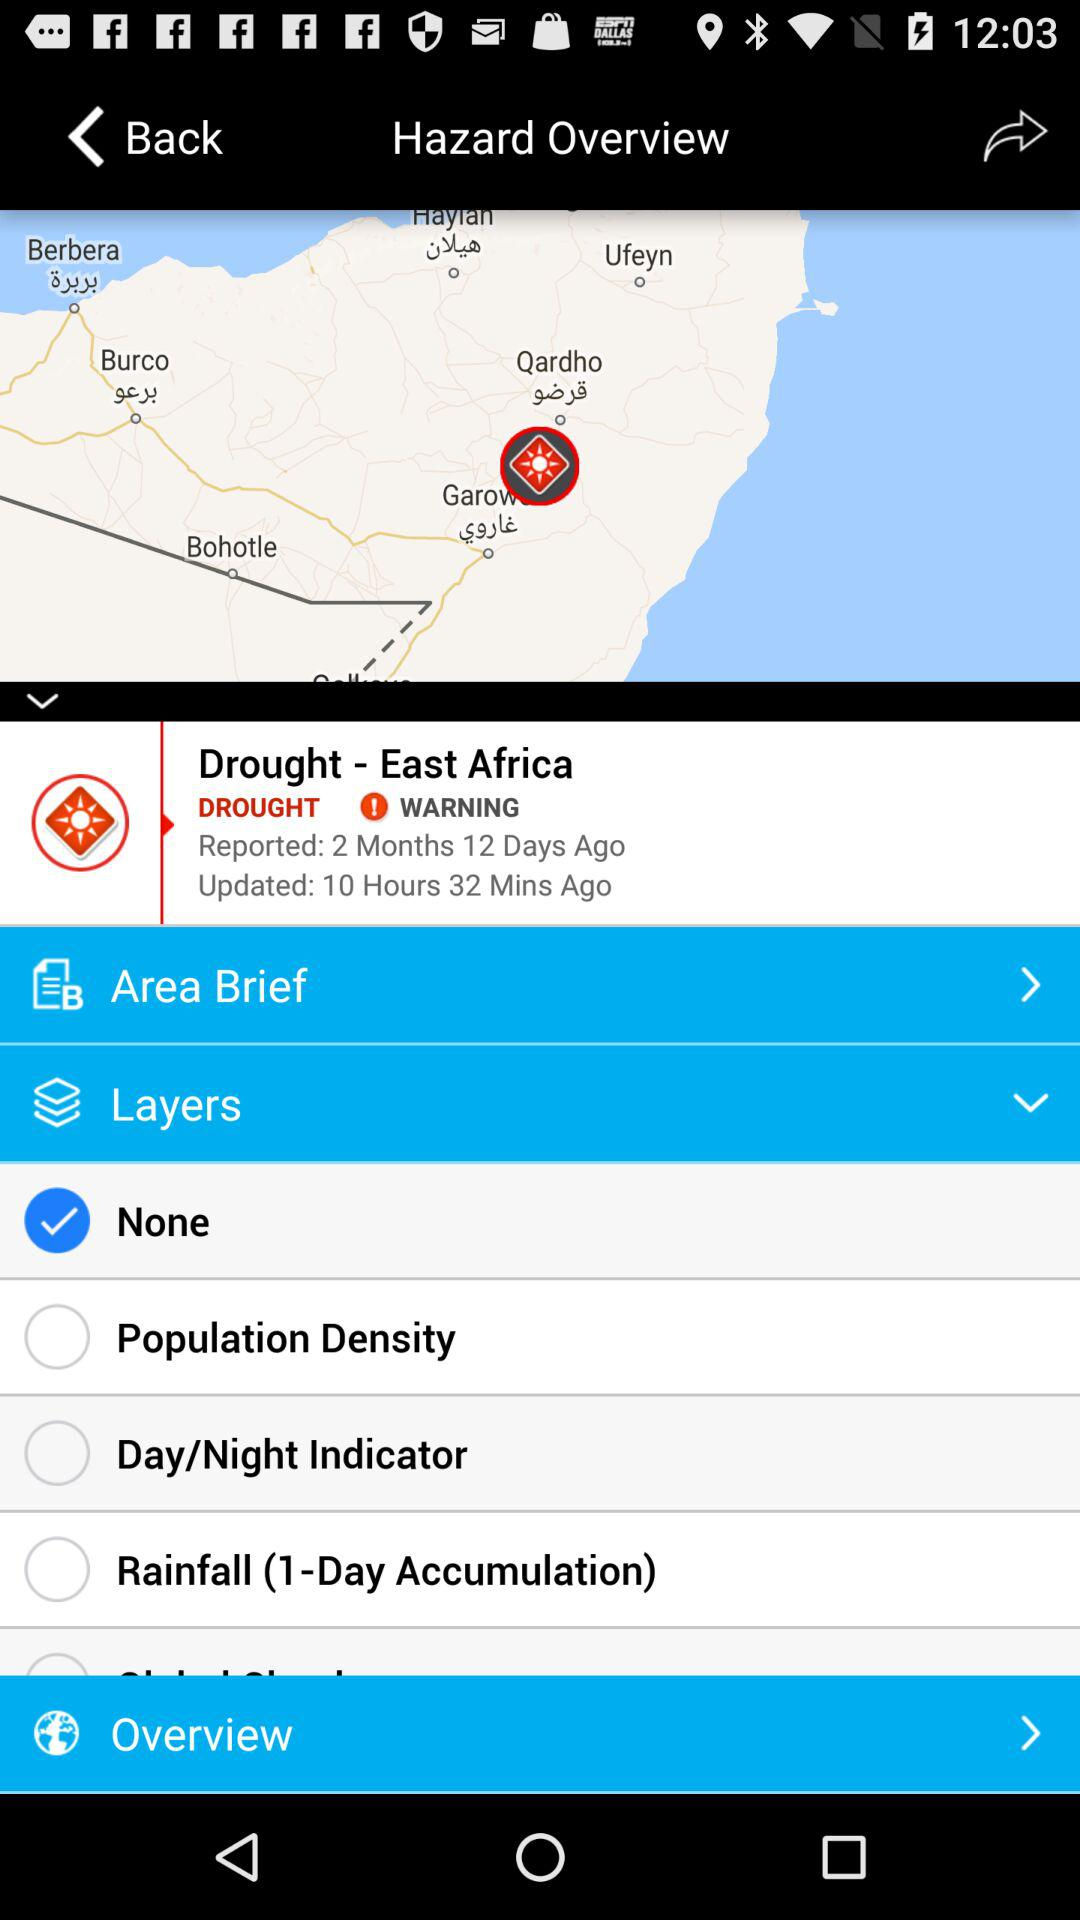How long ago was it last updated? It was last updated 10 hours 32 minutes ago. 